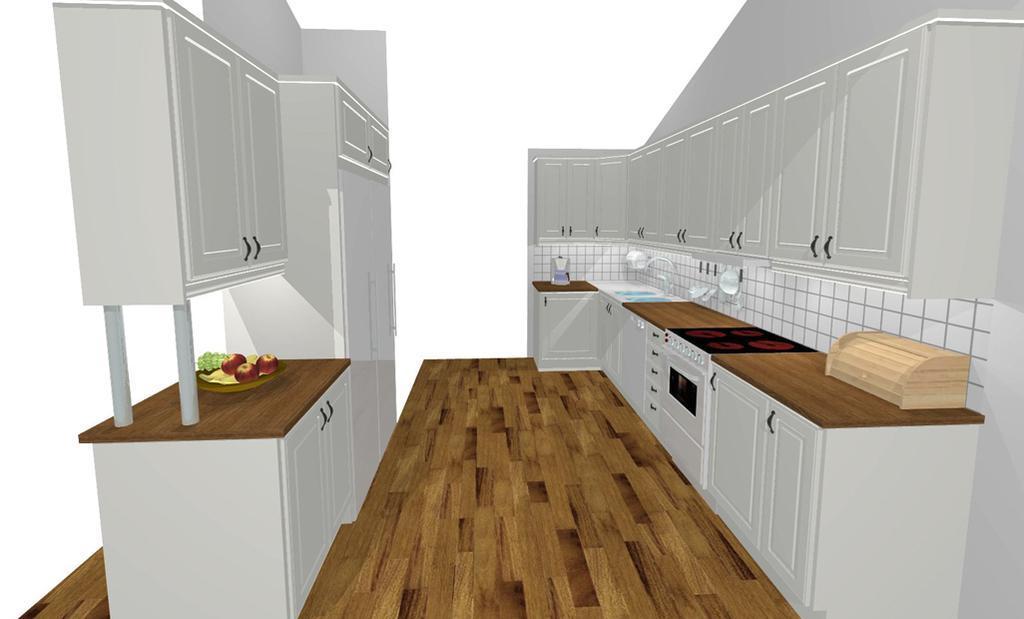Please provide a concise description of this image. This image is a depiction and in this image we can see some shelves with doors. We can also see some fruits in the plate. At the bottom there is floor. 